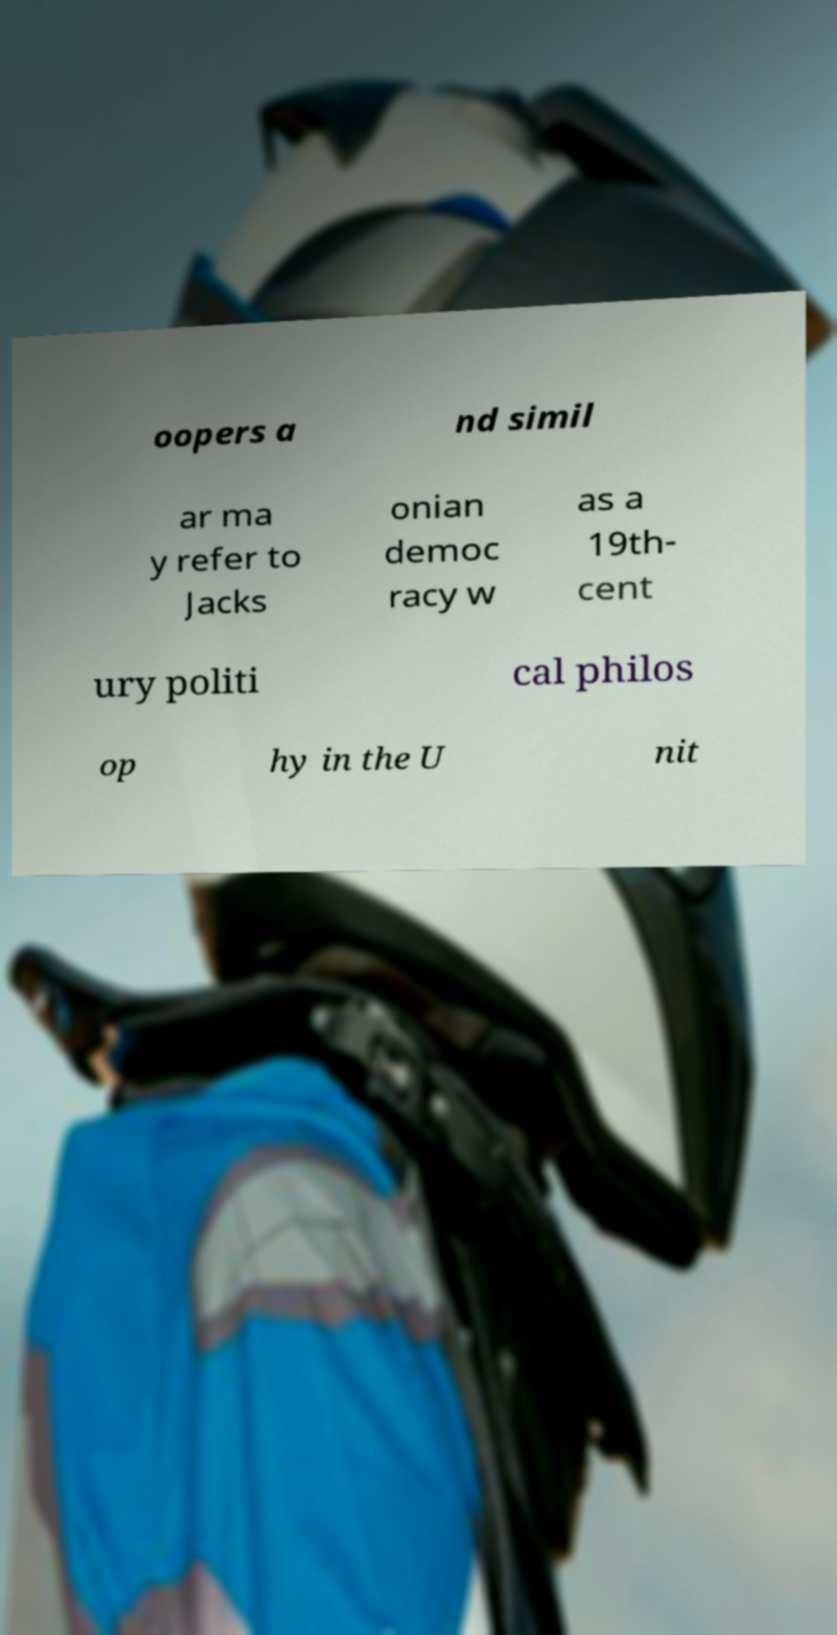I need the written content from this picture converted into text. Can you do that? oopers a nd simil ar ma y refer to Jacks onian democ racy w as a 19th- cent ury politi cal philos op hy in the U nit 